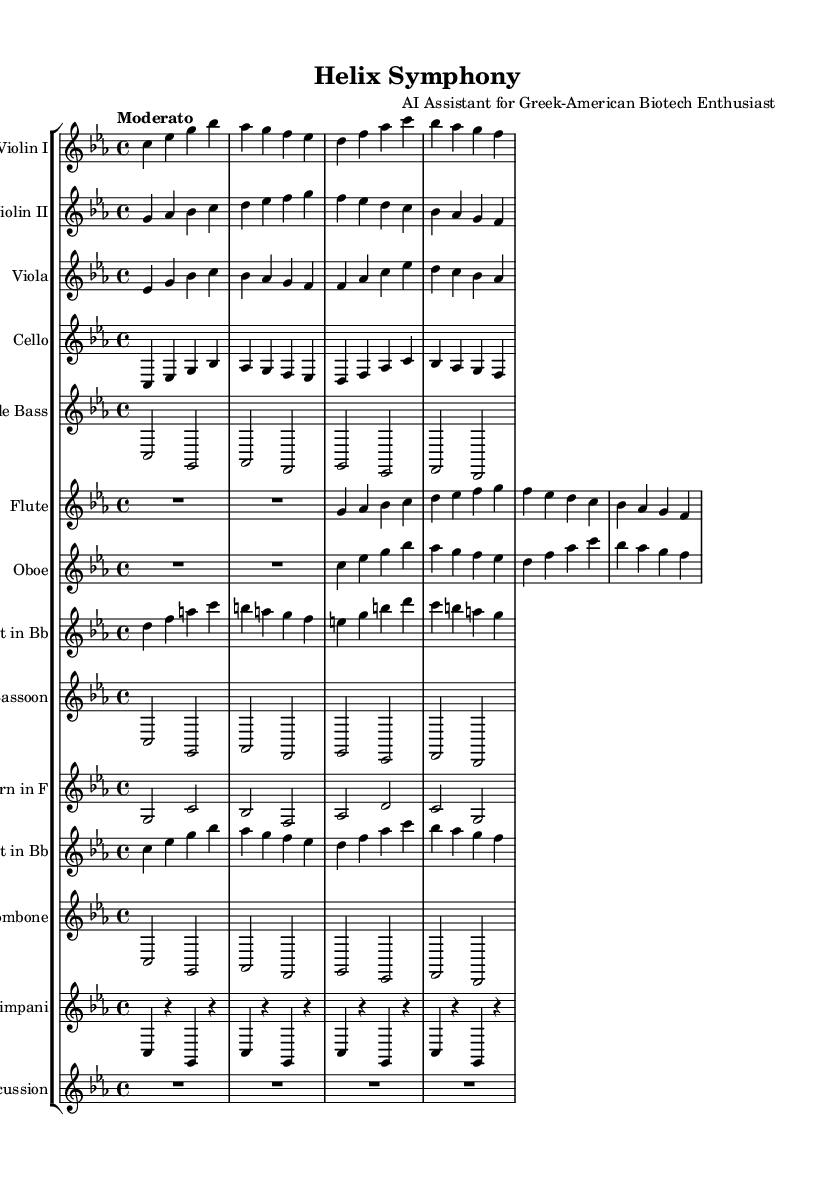What is the key signature of this music? The key signature is C minor, which has three flats (B♭, E♭, A♭) indicated at the beginning of the staff.
Answer: C minor What is the time signature of this piece? The time signature is indicated as 4/4, meaning there are four beats in each measure and the quarter note receives one beat.
Answer: 4/4 What is the tempo marking for this symphony? The tempo marking at the beginning indicates "Moderato," suggesting a moderate speed for the performance.
Answer: Moderato How many different instruments are included in this score? By counting the separate staves for each instrument, there are 13 different instruments listed in the score.
Answer: 13 Which instrument has the highest pitch range in this symphony? The flute, depicted in the second octave relative to 'c', typically has one of the highest pitch ranges among orchestral instruments listed in the score.
Answer: Flute What is the rhythmic value of the first note in the flute part? The first note in the flute part is a whole note, as indicated by the rest preceding it, which allows for a duration of four beats with no subdivisions.
Answer: Whole note Which instrument section is represented by the lowest pitch in the score? The double bass section, positioned as a separate staff at the bottom of the score, typically plays the lowest pitches in orchestral works.
Answer: Double Bass 